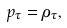<formula> <loc_0><loc_0><loc_500><loc_500>p _ { \tau } = \rho _ { \tau } ,</formula> 